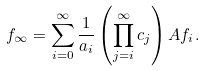<formula> <loc_0><loc_0><loc_500><loc_500>f _ { \infty } = \sum _ { i = 0 } ^ { \infty } \frac { 1 } { a _ { i } } \left ( \prod _ { j = i } ^ { \infty } c _ { j } \right ) A f _ { i } .</formula> 